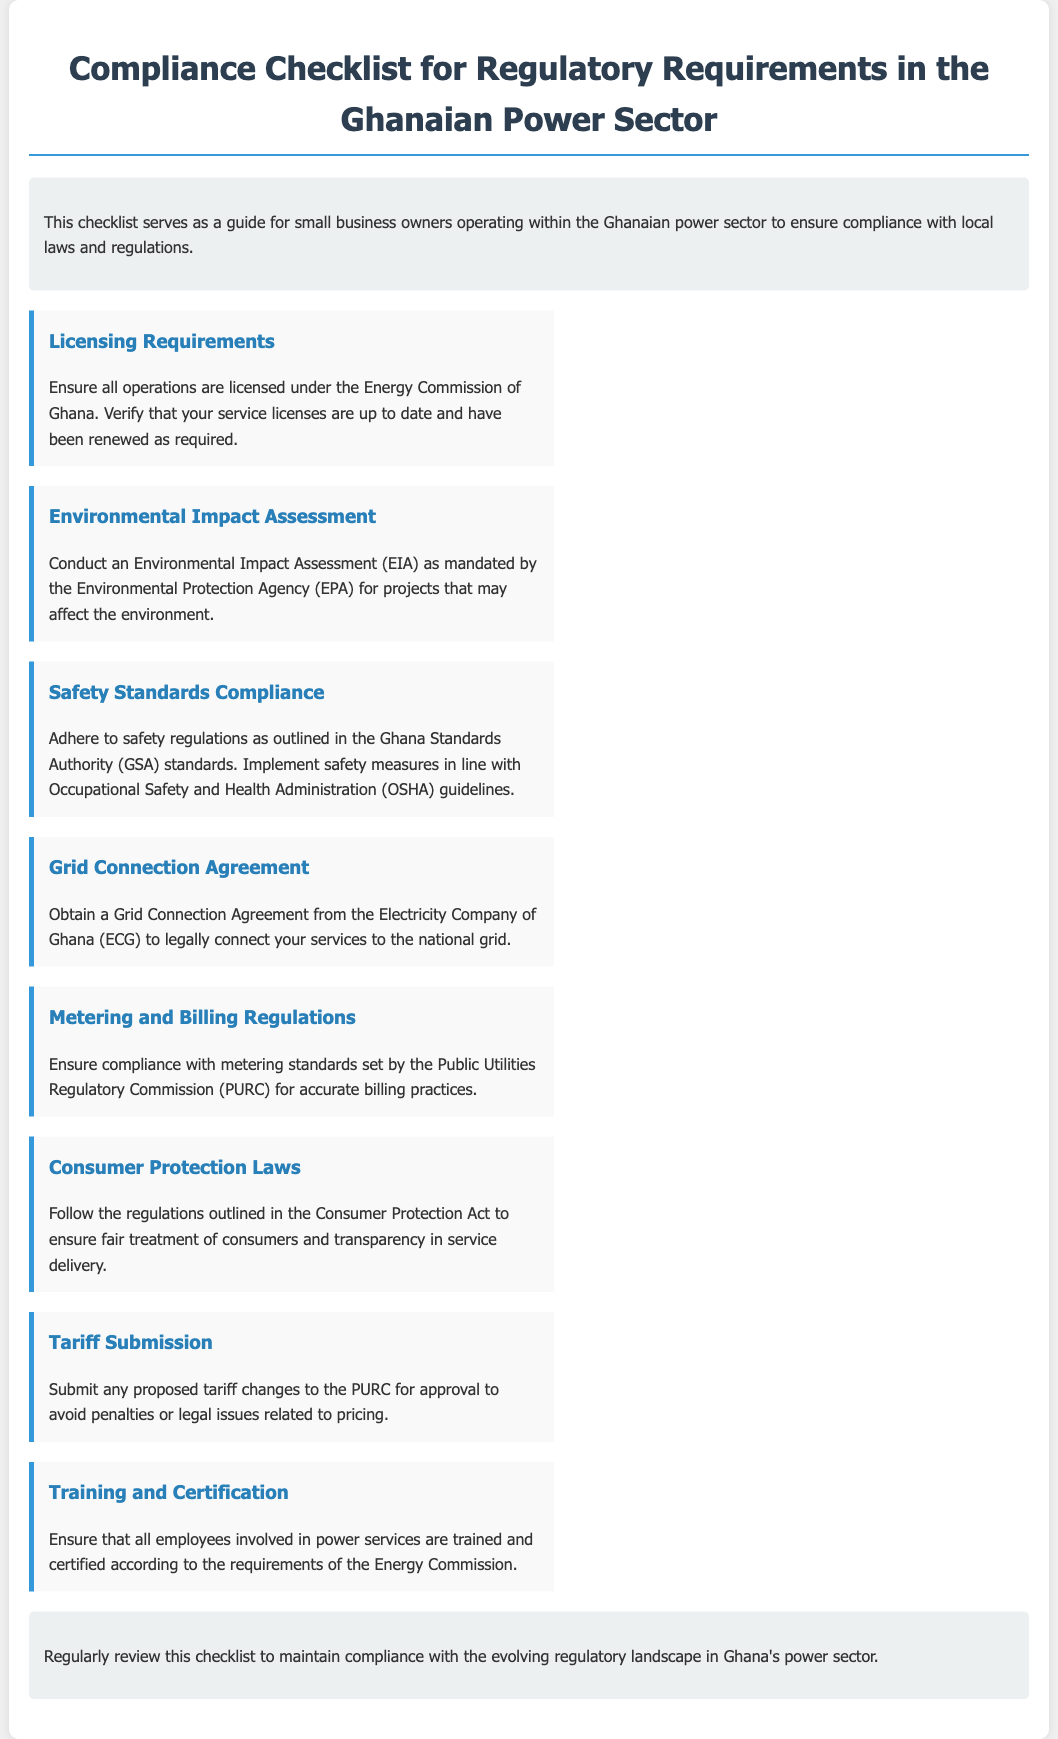what is the title of the document? The title of the document is prominently displayed at the top as "Compliance Checklist for Regulatory Requirements in the Ghanaian Power Sector."
Answer: Compliance Checklist for Regulatory Requirements in the Ghanaian Power Sector who is responsible for licensing operations in Ghana's power sector? The licensing operations are governed by the Energy Commission of Ghana, which is mentioned in the Licensing Requirements section.
Answer: Energy Commission of Ghana what must be conducted as mandated by the EPA? The document states that an Environmental Impact Assessment is mandated by the Environmental Protection Agency for certain projects.
Answer: Environmental Impact Assessment which authority outlines safety standards compliance? The Ghana Standards Authority is referenced as the authority for safety standards compliance in the document.
Answer: Ghana Standards Authority what is required to connect services to the national grid? The document specifies that a Grid Connection Agreement from the Electricity Company of Ghana is required for connecting services.
Answer: Grid Connection Agreement which commission regulates metering standards? The Public Utilities Regulatory Commission is responsible for the metering standards as noted in the Metering and Billing Regulations section.
Answer: Public Utilities Regulatory Commission what act should be followed for consumer protection? The document mentions the Consumer Protection Act that outlines regulations for consumer protection.
Answer: Consumer Protection Act who must be trained and certified according to the document? The document indicates that all employees involved in power services must be trained and certified according to the requirements of the Energy Commission.
Answer: Employees involved in power services 